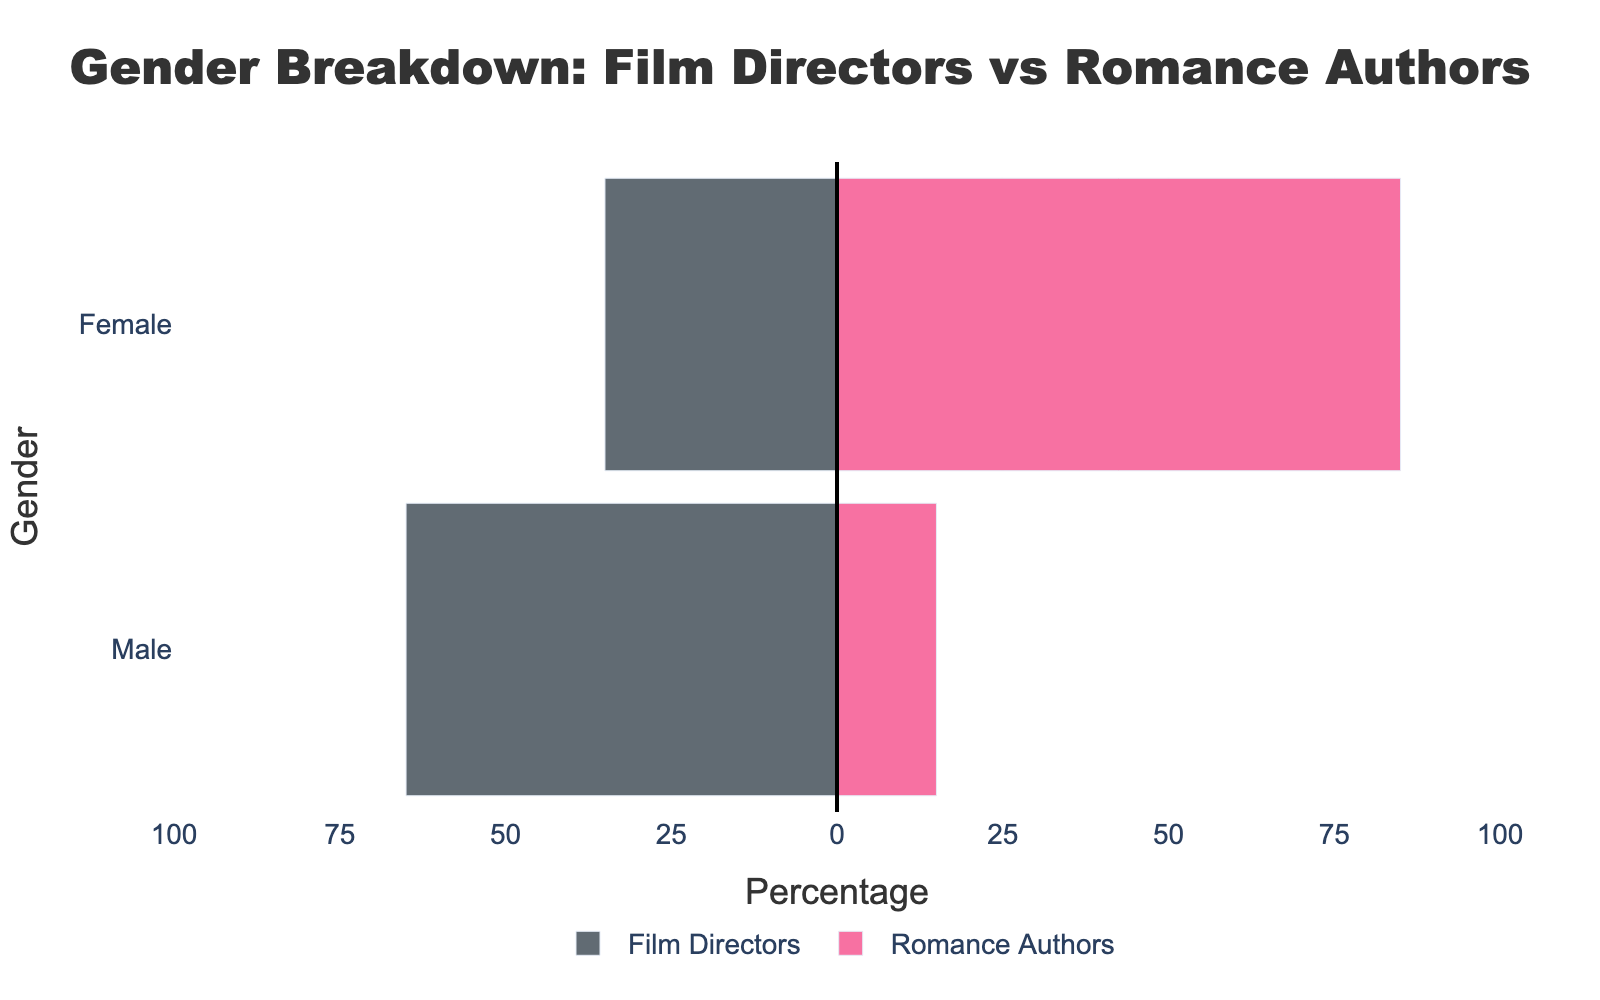What is the title of the figure? The title of the figure is displayed at the top of the chart in a larger font size indicating the theme of the visualization.
Answer: Gender Breakdown: Film Directors vs Romance Authors What percentage of film directors are male? The x-axis of the left side of the diagram shows negative values representing film directors, and the bar corresponding to 'Male' stretches to -65%.
Answer: 65% What percentage of romance authors are female? The x-axis of the right side of the diagram shows positive values representing romance authors, and the bar corresponding to 'Female' extends to 85%.
Answer: 85% Which gender has a greater representation among film directors? By comparing the length of the bars in the 'Film Directors' category, the bar for 'Male' is longer than 'Female', indicating greater representation.
Answer: Male Which gender has a greater representation among romance authors? By comparing the length of the bars in the 'Romance Authors' category, the bar for 'Female' is longer than 'Male', indicating greater representation.
Answer: Female What is the difference in male representation between film directors and romance authors? The chart shows 65% male for film directors and 15% male for romance authors. The difference is calculated as 65% - 15%.
Answer: 50% What is the combined percentage of female and male romance authors? The bar lengths for 'Female' and 'Male' romance authors are 85% and 15%, respectively. Adding these up gives the total percentage.
Answer: 100% How does the gender distribution of romance authors compare to film directors? The bar for male film directors is significantly longer than that for male romance authors, while the bar for female romance authors is significantly longer than that for female film directors.
Answer: Male-dominated for film directors; Female-dominated for romance authors Is there a balanced gender distribution among film directors? By examining the chart, we can see that male representation is nearly double that of female representation among film directors, indicating an unbalanced distribution.
Answer: No Is the distribution of romance authors skewed more towards one gender? The bar corresponding to 'Female' extends to 85% while the bar for 'Male' is only 15%, showing a skewed distribution.
Answer: Yes 